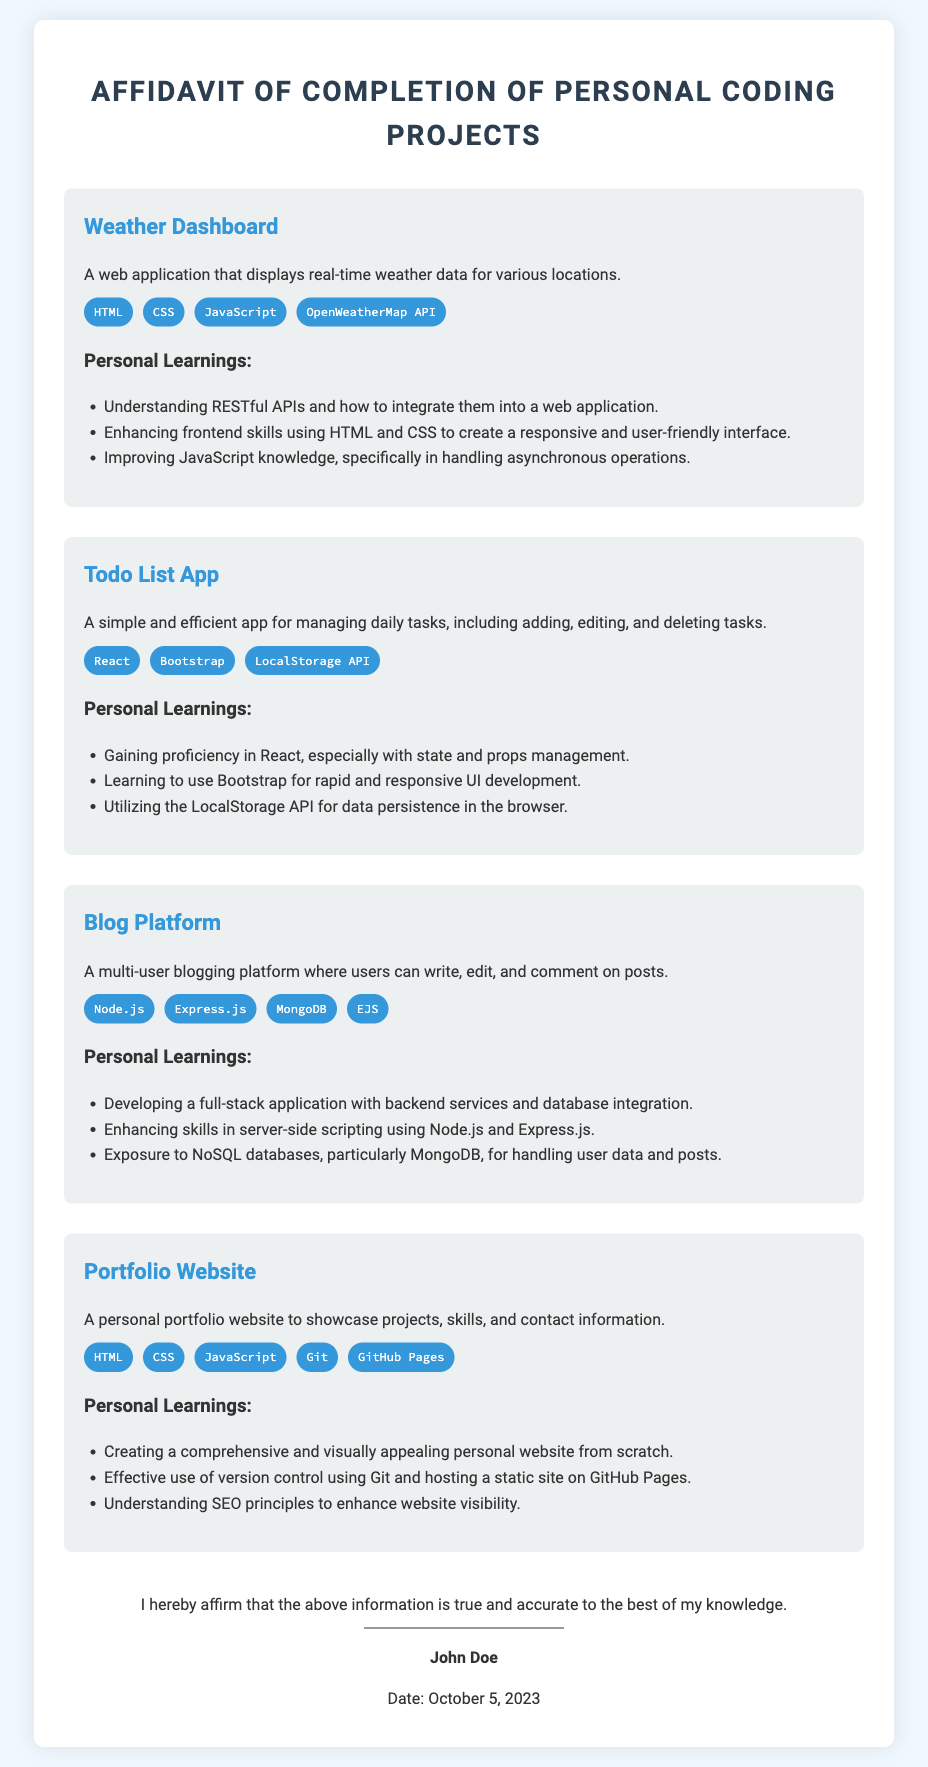what is the title of the affidavit? The title of the affidavit is presented at the top of the document.
Answer: Affidavit of Completion of Personal Coding Projects who is the author of the affidavit? The author's name is stated at the end of the document.
Answer: John Doe what date was the affidavit signed? The signed date is clearly mentioned near the author's name.
Answer: October 5, 2023 how many personal projects are described in the affidavit? The number of projects can be counted from the sections dedicated to each project in the document.
Answer: Four what technology is used in the Weather Dashboard project? The technologies used are listed under each project description.
Answer: OpenWeatherMap API what personal learning is associated with the Todo List App? The personal learnings are specific to each project and can be found under the respective sections.
Answer: Gaining proficiency in React which project involved backend services? This requires knowledge of the projects that include server-side components.
Answer: Blog Platform which project uses Bootstrap? The technology listing for each project helps identify relevant technologies used.
Answer: Todo List App what is the purpose of the Portfolio Website? The purpose is described in a short paragraph under the project section.
Answer: To showcase projects, skills, and contact information 